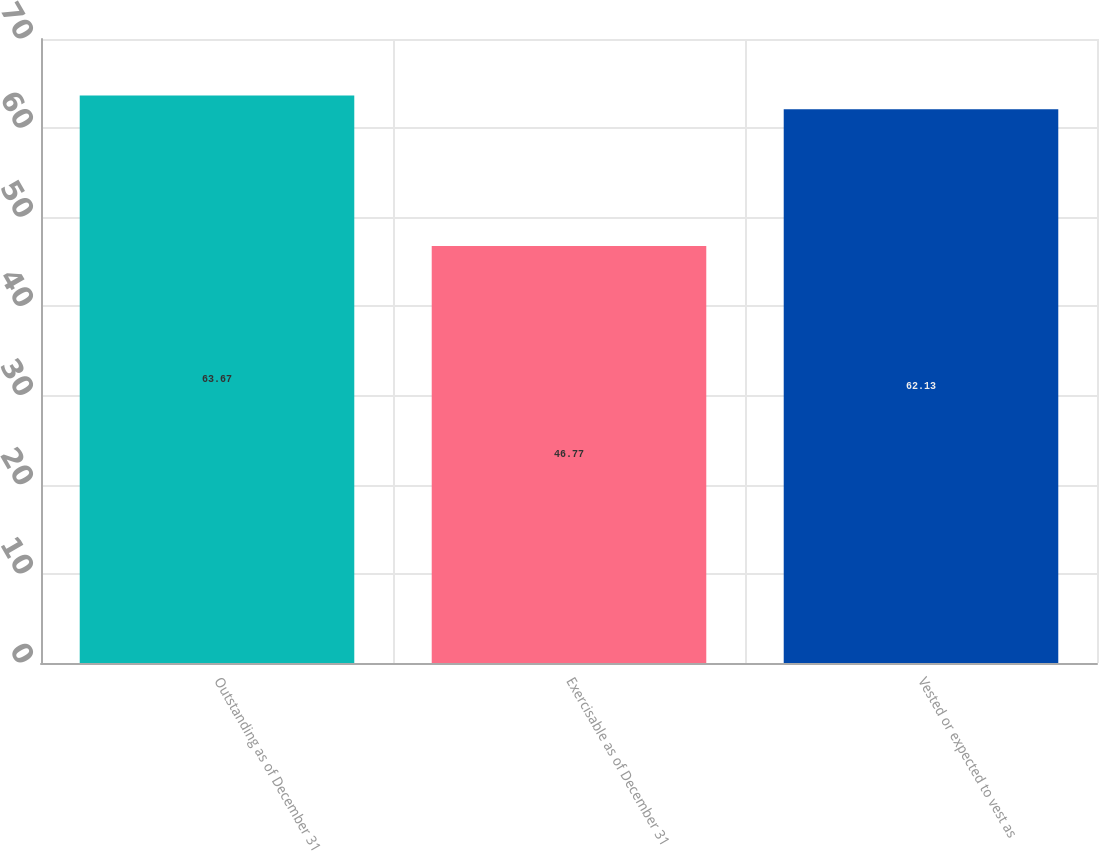<chart> <loc_0><loc_0><loc_500><loc_500><bar_chart><fcel>Outstanding as of December 31<fcel>Exercisable as of December 31<fcel>Vested or expected to vest as<nl><fcel>63.67<fcel>46.77<fcel>62.13<nl></chart> 